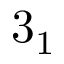<formula> <loc_0><loc_0><loc_500><loc_500>3 _ { 1 }</formula> 